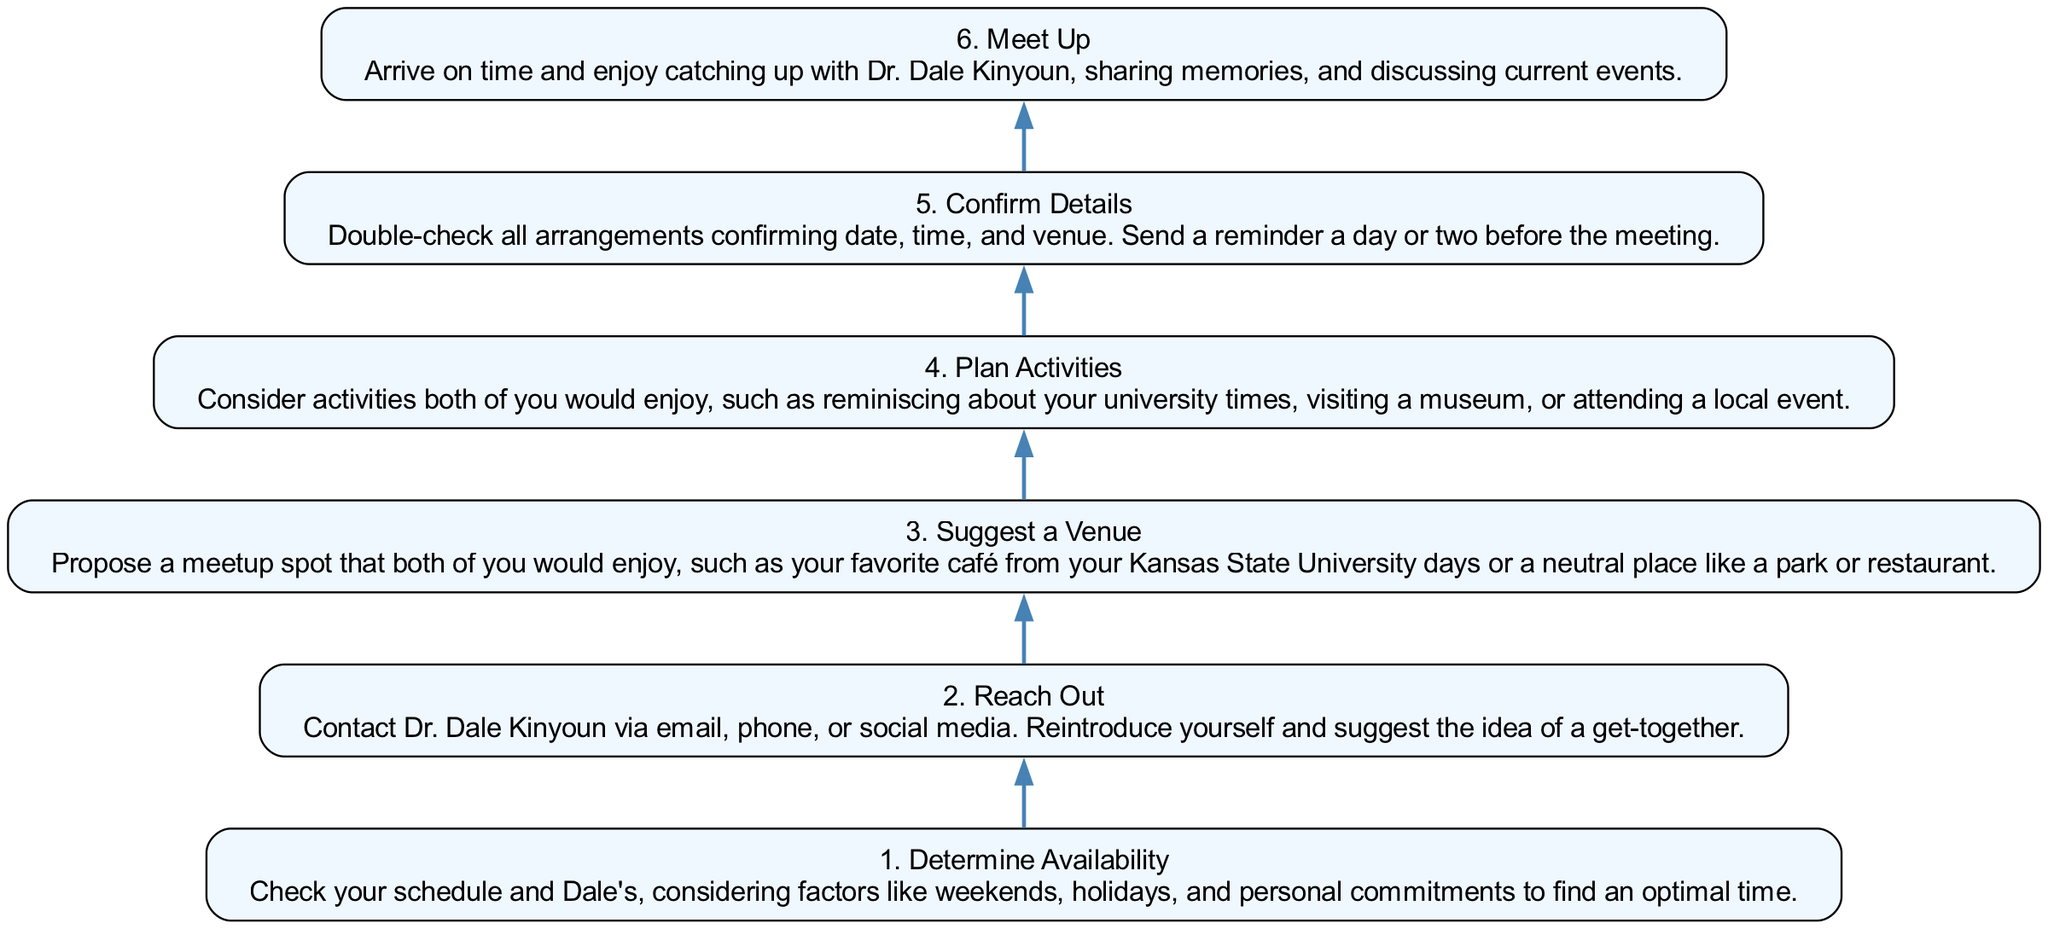What is the first step in organizing a get-together? The first step is "Determine Availability," which involves checking schedules and personal commitments to find an optimal time.
Answer: Determine Availability How many total steps are there in the diagram? The diagram includes six steps, which are sequentially laid out from the bottom to the top.
Answer: 6 Which step comes after "Reach Out"? The step that comes next is "Suggest a Venue," indicating it follows the outreach phase in the process.
Answer: Suggest a Venue What is the last activity indicated in the flow chart? The final activity is "Meet Up," where the actual gathering and catching up happen with Dr. Dale Kinyoun.
Answer: Meet Up What would you confirm in the "Confirm Details" step? In this step, you would confirm the date, time, and venue, ensuring all arrangements are in place before the meeting.
Answer: Date, time, and venue What is the purpose of the "Plan Activities" step? The purpose is to consider enjoyable activities for the get-together, enhancing the experience through shared interests.
Answer: Consider activities What is the relationship between "Suggest a Venue" and "Plan Activities"? "Suggest a Venue" is a prerequisite to "Plan Activities," as selecting the location often influences the types of activities you can plan.
Answer: Prerequisite What action should be taken before the meeting in the "Confirm Details" step? You should send a reminder a day or two before the meeting to ensure that both parties remember the arrangements.
Answer: Send a reminder 